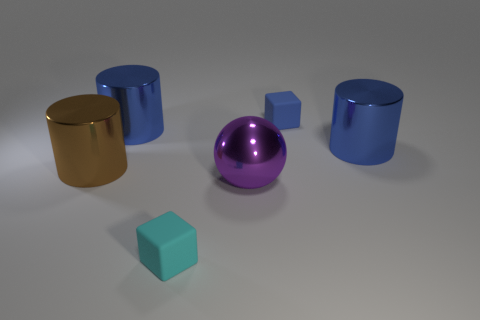Add 2 brown objects. How many objects exist? 8 Subtract all balls. How many objects are left? 5 Subtract all tiny purple rubber balls. Subtract all big blue objects. How many objects are left? 4 Add 1 shiny objects. How many shiny objects are left? 5 Add 4 cylinders. How many cylinders exist? 7 Subtract 0 green cylinders. How many objects are left? 6 